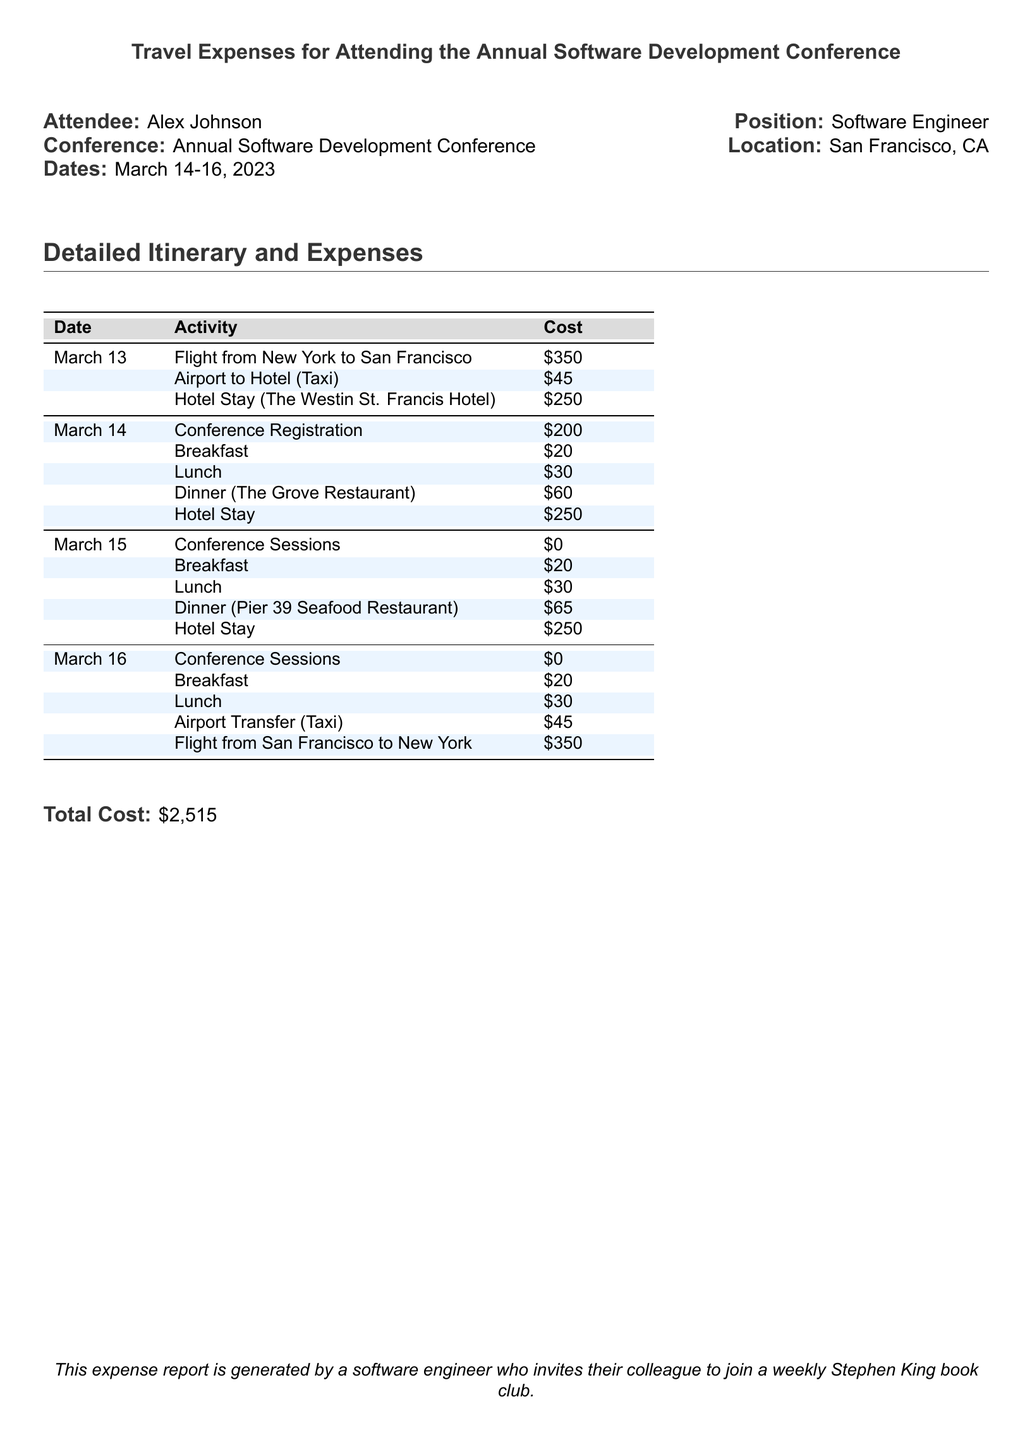What is the total cost of the trip? The total cost is listed at the end of the expense report, which sums all expenses incurred during the trip.
Answer: $2,515 How many nights did Alex stay at the hotel? The itinerary indicates hotel stays for three separate dates, each corresponding to a night of stay.
Answer: 3 What was the cost of the flight from New York to San Francisco? The expense report specifies the flight cost as listed on March 13.
Answer: $350 What meals were provided on March 14? The itinerary details the meals consumed on this date, which include breakfast, lunch, and dinner.
Answer: Breakfast, Lunch, Dinner How much was spent on dinners during the trip? The report lists the cost of dinners for two nights, March 14 and March 15, which can be summed.
Answer: $125 What date does the conference take place? The travel dates listed indicate the conference days, specifically noting the dates of March 14-16.
Answer: March 14-16, 2023 How much was spent on conference registration? The document explicitly states the registration cost in the itinerary.
Answer: $200 What transportation method was used from the airport to the hotel? The report specifies the use of a taxi for this transfer, as outlined in the itinerary.
Answer: Taxi Where did Alex have dinner on March 15? The expense document indicates the name of the restaurant where dinner was held on this date.
Answer: Pier 39 Seafood Restaurant 